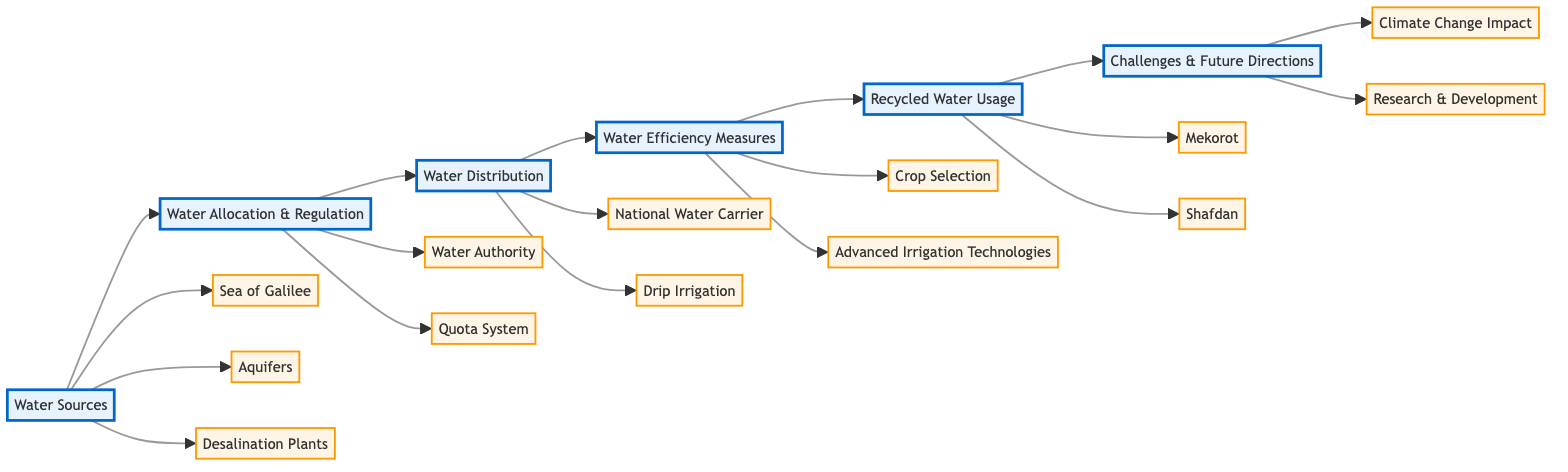What are the main categories of water management in Israeli agriculture? The diagram outlines six main categories: Water Sources, Water Allocation & Regulation, Water Distribution, Water Efficiency Measures, Recycled Water Usage, and Challenges & Future Directions.
Answer: Six How many sub-elements are associated with Water Sources? There are three sub-elements under Water Sources: Sea of Galilee, Aquifers, and Desalination Plants.
Answer: Three What method is mentioned for efficient irrigation in the Water Distribution category? The diagram lists Drip Irrigation as the efficient irrigation method. It highlights its effectiveness in delivering small amounts of water directly to plant roots.
Answer: Drip Irrigation Which category follows Water Allocation & Regulation? Water Distribution follows Water Allocation & Regulation in the flowchart sequence. By analyzing the flow connections, we can trace that Water Distribution is directly linked after the second category.
Answer: Water Distribution What are the two components listed under Challenges & Future Directions? The components listed are Climate Change Impact and Research & Development, representing the current challenges and future strategies in water management.
Answer: Climate Change Impact, Research & Development Which governmental body oversees water allocation, according to the flowchart? The Water Authority is identified as the governmental body responsible for overseeing water allocation in the Water Allocation & Regulation category.
Answer: Water Authority What technology is mentioned under Water Efficiency Measures that optimizes water use? Advanced Irrigation Technologies, which includes the use of sensors and automation, is mentioned for optimizing water use under the Water Efficiency Measures category.
Answer: Advanced Irrigation Technologies Which two facilities are responsible for recycled water usage in agriculture? Mekorot and Shafdan are identified as the key facilities for utilizing treated wastewater in agriculture under the Recycled Water Usage category.
Answer: Mekorot, Shafdan 